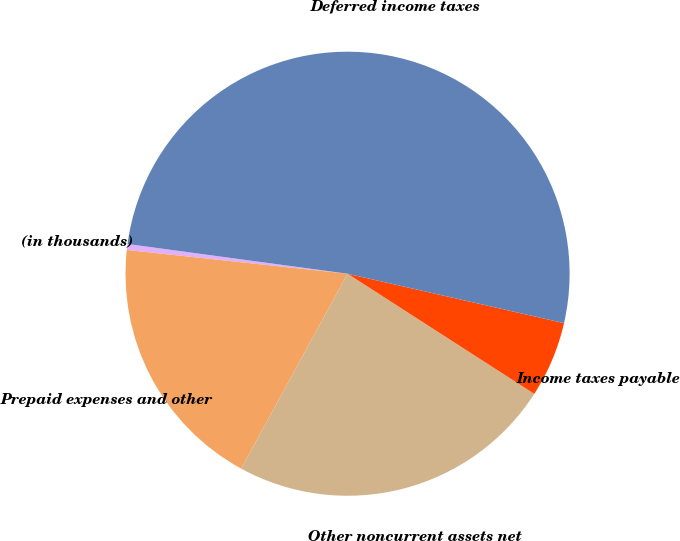Convert chart to OTSL. <chart><loc_0><loc_0><loc_500><loc_500><pie_chart><fcel>(in thousands)<fcel>Prepaid expenses and other<fcel>Other noncurrent assets net<fcel>Income taxes payable<fcel>Deferred income taxes<nl><fcel>0.43%<fcel>18.75%<fcel>23.85%<fcel>5.53%<fcel>51.43%<nl></chart> 